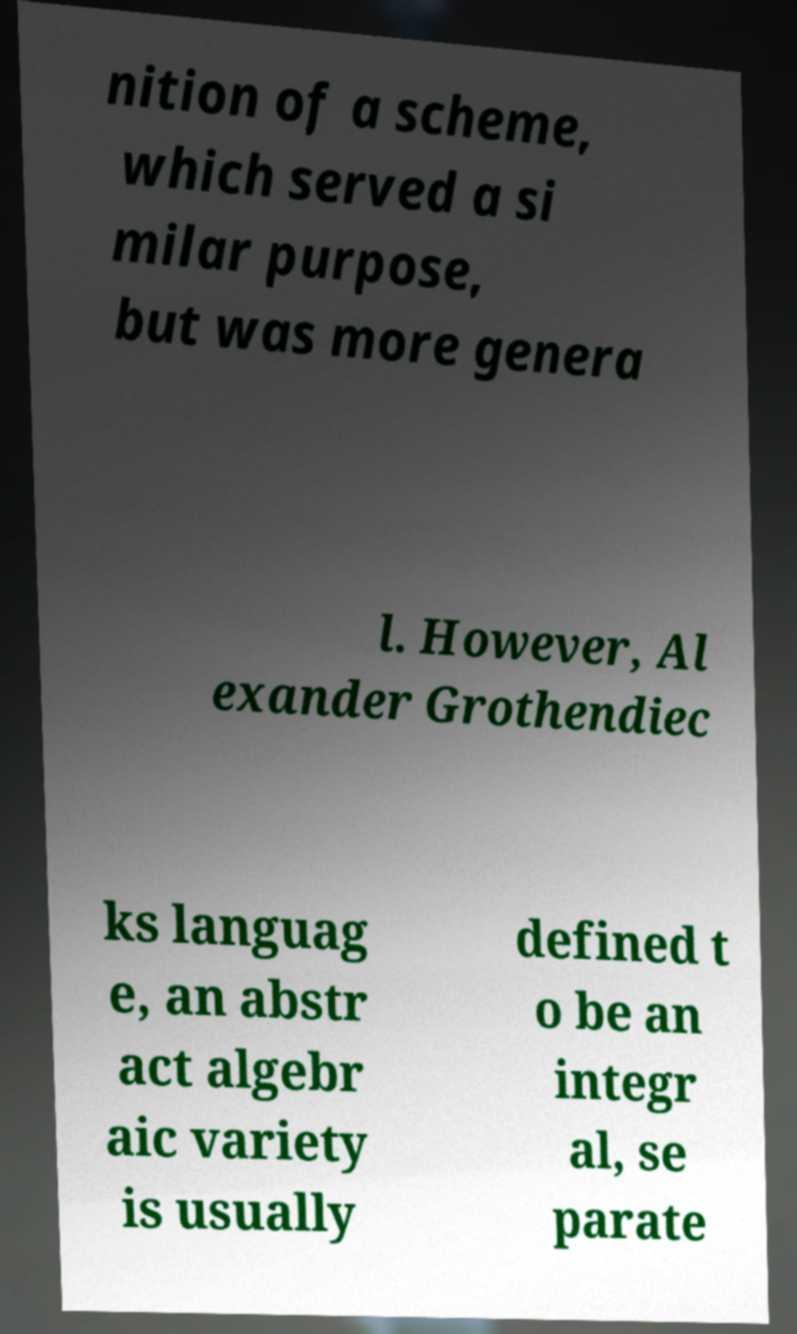There's text embedded in this image that I need extracted. Can you transcribe it verbatim? nition of a scheme, which served a si milar purpose, but was more genera l. However, Al exander Grothendiec ks languag e, an abstr act algebr aic variety is usually defined t o be an integr al, se parate 